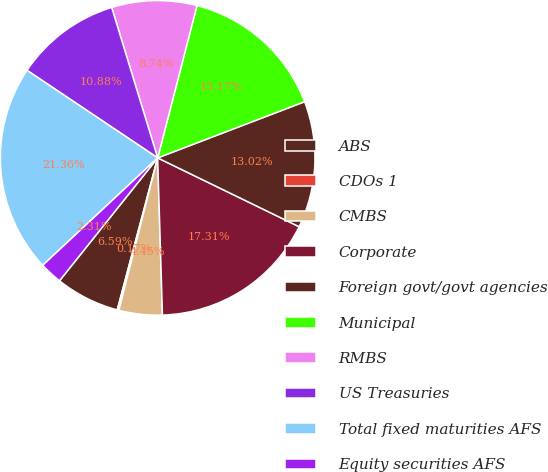Convert chart to OTSL. <chart><loc_0><loc_0><loc_500><loc_500><pie_chart><fcel>ABS<fcel>CDOs 1<fcel>CMBS<fcel>Corporate<fcel>Foreign govt/govt agencies<fcel>Municipal<fcel>RMBS<fcel>US Treasuries<fcel>Total fixed maturities AFS<fcel>Equity securities AFS<nl><fcel>6.59%<fcel>0.17%<fcel>4.45%<fcel>17.31%<fcel>13.02%<fcel>15.17%<fcel>8.74%<fcel>10.88%<fcel>21.36%<fcel>2.31%<nl></chart> 